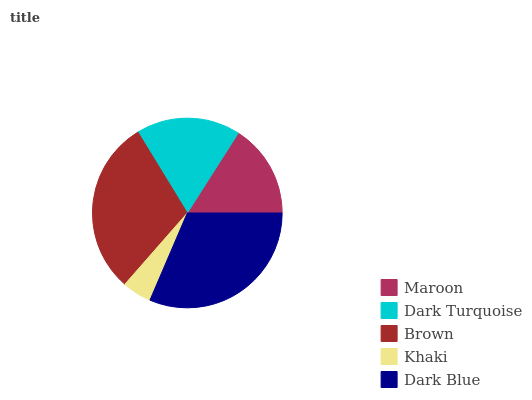Is Khaki the minimum?
Answer yes or no. Yes. Is Dark Blue the maximum?
Answer yes or no. Yes. Is Dark Turquoise the minimum?
Answer yes or no. No. Is Dark Turquoise the maximum?
Answer yes or no. No. Is Dark Turquoise greater than Maroon?
Answer yes or no. Yes. Is Maroon less than Dark Turquoise?
Answer yes or no. Yes. Is Maroon greater than Dark Turquoise?
Answer yes or no. No. Is Dark Turquoise less than Maroon?
Answer yes or no. No. Is Dark Turquoise the high median?
Answer yes or no. Yes. Is Dark Turquoise the low median?
Answer yes or no. Yes. Is Brown the high median?
Answer yes or no. No. Is Khaki the low median?
Answer yes or no. No. 